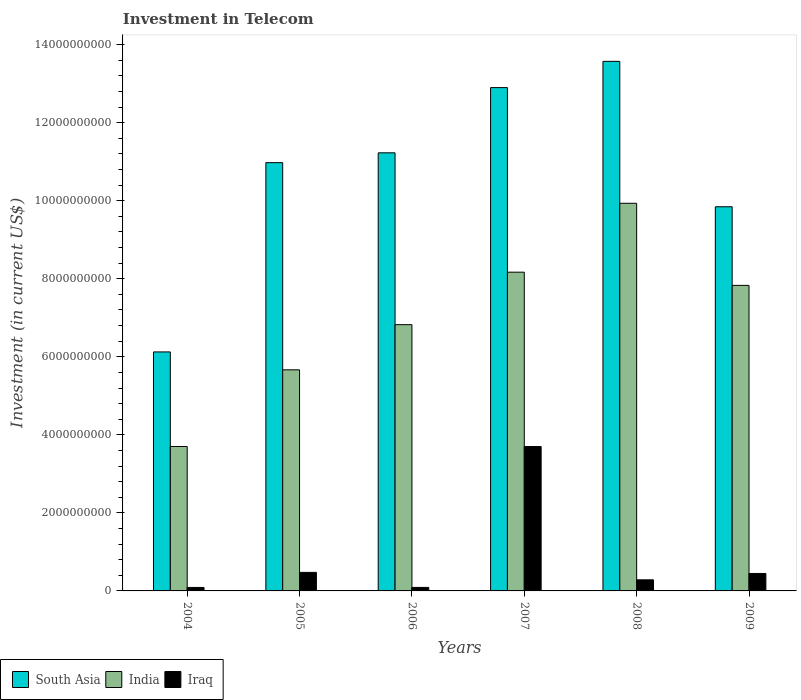Are the number of bars per tick equal to the number of legend labels?
Give a very brief answer. Yes. Are the number of bars on each tick of the X-axis equal?
Provide a short and direct response. Yes. How many bars are there on the 3rd tick from the right?
Keep it short and to the point. 3. In how many cases, is the number of bars for a given year not equal to the number of legend labels?
Ensure brevity in your answer.  0. What is the amount invested in telecom in South Asia in 2006?
Ensure brevity in your answer.  1.12e+1. Across all years, what is the maximum amount invested in telecom in South Asia?
Your response must be concise. 1.36e+1. Across all years, what is the minimum amount invested in telecom in India?
Your answer should be compact. 3.70e+09. In which year was the amount invested in telecom in Iraq maximum?
Offer a very short reply. 2007. What is the total amount invested in telecom in Iraq in the graph?
Ensure brevity in your answer.  5.08e+09. What is the difference between the amount invested in telecom in South Asia in 2004 and that in 2008?
Give a very brief answer. -7.45e+09. What is the difference between the amount invested in telecom in Iraq in 2008 and the amount invested in telecom in South Asia in 2006?
Provide a succinct answer. -1.09e+1. What is the average amount invested in telecom in Iraq per year?
Provide a short and direct response. 8.48e+08. In the year 2009, what is the difference between the amount invested in telecom in Iraq and amount invested in telecom in India?
Offer a very short reply. -7.38e+09. In how many years, is the amount invested in telecom in South Asia greater than 12400000000 US$?
Keep it short and to the point. 2. What is the ratio of the amount invested in telecom in Iraq in 2004 to that in 2009?
Give a very brief answer. 0.2. Is the difference between the amount invested in telecom in Iraq in 2005 and 2006 greater than the difference between the amount invested in telecom in India in 2005 and 2006?
Offer a terse response. Yes. What is the difference between the highest and the second highest amount invested in telecom in India?
Your answer should be compact. 1.77e+09. What is the difference between the highest and the lowest amount invested in telecom in Iraq?
Your response must be concise. 3.61e+09. In how many years, is the amount invested in telecom in Iraq greater than the average amount invested in telecom in Iraq taken over all years?
Provide a succinct answer. 1. Is the sum of the amount invested in telecom in South Asia in 2004 and 2008 greater than the maximum amount invested in telecom in India across all years?
Provide a succinct answer. Yes. What does the 3rd bar from the left in 2006 represents?
Give a very brief answer. Iraq. What does the 2nd bar from the right in 2007 represents?
Your response must be concise. India. Are all the bars in the graph horizontal?
Offer a terse response. No. Does the graph contain any zero values?
Provide a short and direct response. No. Where does the legend appear in the graph?
Give a very brief answer. Bottom left. How are the legend labels stacked?
Offer a terse response. Horizontal. What is the title of the graph?
Give a very brief answer. Investment in Telecom. What is the label or title of the Y-axis?
Keep it short and to the point. Investment (in current US$). What is the Investment (in current US$) of South Asia in 2004?
Keep it short and to the point. 6.12e+09. What is the Investment (in current US$) in India in 2004?
Your response must be concise. 3.70e+09. What is the Investment (in current US$) in Iraq in 2004?
Keep it short and to the point. 8.90e+07. What is the Investment (in current US$) in South Asia in 2005?
Your response must be concise. 1.10e+1. What is the Investment (in current US$) of India in 2005?
Make the answer very short. 5.67e+09. What is the Investment (in current US$) in Iraq in 2005?
Offer a very short reply. 4.75e+08. What is the Investment (in current US$) of South Asia in 2006?
Offer a terse response. 1.12e+1. What is the Investment (in current US$) of India in 2006?
Your answer should be compact. 6.82e+09. What is the Investment (in current US$) in Iraq in 2006?
Give a very brief answer. 9.00e+07. What is the Investment (in current US$) in South Asia in 2007?
Offer a terse response. 1.29e+1. What is the Investment (in current US$) of India in 2007?
Provide a short and direct response. 8.17e+09. What is the Investment (in current US$) in Iraq in 2007?
Give a very brief answer. 3.70e+09. What is the Investment (in current US$) of South Asia in 2008?
Offer a terse response. 1.36e+1. What is the Investment (in current US$) in India in 2008?
Your answer should be compact. 9.93e+09. What is the Investment (in current US$) of Iraq in 2008?
Offer a very short reply. 2.84e+08. What is the Investment (in current US$) in South Asia in 2009?
Provide a short and direct response. 9.84e+09. What is the Investment (in current US$) of India in 2009?
Give a very brief answer. 7.83e+09. What is the Investment (in current US$) of Iraq in 2009?
Offer a very short reply. 4.47e+08. Across all years, what is the maximum Investment (in current US$) of South Asia?
Make the answer very short. 1.36e+1. Across all years, what is the maximum Investment (in current US$) of India?
Offer a terse response. 9.93e+09. Across all years, what is the maximum Investment (in current US$) of Iraq?
Keep it short and to the point. 3.70e+09. Across all years, what is the minimum Investment (in current US$) in South Asia?
Offer a very short reply. 6.12e+09. Across all years, what is the minimum Investment (in current US$) in India?
Your answer should be compact. 3.70e+09. Across all years, what is the minimum Investment (in current US$) of Iraq?
Offer a very short reply. 8.90e+07. What is the total Investment (in current US$) of South Asia in the graph?
Offer a terse response. 6.46e+1. What is the total Investment (in current US$) in India in the graph?
Offer a terse response. 4.21e+1. What is the total Investment (in current US$) in Iraq in the graph?
Provide a short and direct response. 5.08e+09. What is the difference between the Investment (in current US$) of South Asia in 2004 and that in 2005?
Ensure brevity in your answer.  -4.85e+09. What is the difference between the Investment (in current US$) of India in 2004 and that in 2005?
Make the answer very short. -1.96e+09. What is the difference between the Investment (in current US$) of Iraq in 2004 and that in 2005?
Your answer should be very brief. -3.86e+08. What is the difference between the Investment (in current US$) of South Asia in 2004 and that in 2006?
Give a very brief answer. -5.10e+09. What is the difference between the Investment (in current US$) in India in 2004 and that in 2006?
Give a very brief answer. -3.12e+09. What is the difference between the Investment (in current US$) in South Asia in 2004 and that in 2007?
Your answer should be very brief. -6.77e+09. What is the difference between the Investment (in current US$) of India in 2004 and that in 2007?
Your answer should be very brief. -4.47e+09. What is the difference between the Investment (in current US$) of Iraq in 2004 and that in 2007?
Offer a terse response. -3.61e+09. What is the difference between the Investment (in current US$) in South Asia in 2004 and that in 2008?
Provide a succinct answer. -7.45e+09. What is the difference between the Investment (in current US$) in India in 2004 and that in 2008?
Ensure brevity in your answer.  -6.23e+09. What is the difference between the Investment (in current US$) in Iraq in 2004 and that in 2008?
Make the answer very short. -1.95e+08. What is the difference between the Investment (in current US$) in South Asia in 2004 and that in 2009?
Your answer should be very brief. -3.72e+09. What is the difference between the Investment (in current US$) in India in 2004 and that in 2009?
Your answer should be compact. -4.13e+09. What is the difference between the Investment (in current US$) of Iraq in 2004 and that in 2009?
Your answer should be very brief. -3.58e+08. What is the difference between the Investment (in current US$) in South Asia in 2005 and that in 2006?
Offer a terse response. -2.52e+08. What is the difference between the Investment (in current US$) of India in 2005 and that in 2006?
Your answer should be very brief. -1.16e+09. What is the difference between the Investment (in current US$) in Iraq in 2005 and that in 2006?
Your answer should be compact. 3.85e+08. What is the difference between the Investment (in current US$) of South Asia in 2005 and that in 2007?
Offer a terse response. -1.92e+09. What is the difference between the Investment (in current US$) in India in 2005 and that in 2007?
Give a very brief answer. -2.50e+09. What is the difference between the Investment (in current US$) of Iraq in 2005 and that in 2007?
Your response must be concise. -3.22e+09. What is the difference between the Investment (in current US$) of South Asia in 2005 and that in 2008?
Your answer should be very brief. -2.60e+09. What is the difference between the Investment (in current US$) of India in 2005 and that in 2008?
Provide a short and direct response. -4.27e+09. What is the difference between the Investment (in current US$) in Iraq in 2005 and that in 2008?
Offer a terse response. 1.91e+08. What is the difference between the Investment (in current US$) of South Asia in 2005 and that in 2009?
Offer a very short reply. 1.13e+09. What is the difference between the Investment (in current US$) of India in 2005 and that in 2009?
Your answer should be compact. -2.16e+09. What is the difference between the Investment (in current US$) in Iraq in 2005 and that in 2009?
Ensure brevity in your answer.  2.80e+07. What is the difference between the Investment (in current US$) of South Asia in 2006 and that in 2007?
Keep it short and to the point. -1.67e+09. What is the difference between the Investment (in current US$) in India in 2006 and that in 2007?
Offer a terse response. -1.35e+09. What is the difference between the Investment (in current US$) in Iraq in 2006 and that in 2007?
Your answer should be compact. -3.61e+09. What is the difference between the Investment (in current US$) in South Asia in 2006 and that in 2008?
Your response must be concise. -2.34e+09. What is the difference between the Investment (in current US$) in India in 2006 and that in 2008?
Keep it short and to the point. -3.11e+09. What is the difference between the Investment (in current US$) in Iraq in 2006 and that in 2008?
Your answer should be very brief. -1.94e+08. What is the difference between the Investment (in current US$) in South Asia in 2006 and that in 2009?
Keep it short and to the point. 1.38e+09. What is the difference between the Investment (in current US$) in India in 2006 and that in 2009?
Your response must be concise. -1.01e+09. What is the difference between the Investment (in current US$) of Iraq in 2006 and that in 2009?
Ensure brevity in your answer.  -3.57e+08. What is the difference between the Investment (in current US$) in South Asia in 2007 and that in 2008?
Offer a very short reply. -6.73e+08. What is the difference between the Investment (in current US$) in India in 2007 and that in 2008?
Ensure brevity in your answer.  -1.77e+09. What is the difference between the Investment (in current US$) in Iraq in 2007 and that in 2008?
Provide a short and direct response. 3.42e+09. What is the difference between the Investment (in current US$) of South Asia in 2007 and that in 2009?
Your response must be concise. 3.05e+09. What is the difference between the Investment (in current US$) of India in 2007 and that in 2009?
Your answer should be very brief. 3.38e+08. What is the difference between the Investment (in current US$) of Iraq in 2007 and that in 2009?
Ensure brevity in your answer.  3.25e+09. What is the difference between the Investment (in current US$) in South Asia in 2008 and that in 2009?
Provide a succinct answer. 3.73e+09. What is the difference between the Investment (in current US$) in India in 2008 and that in 2009?
Make the answer very short. 2.10e+09. What is the difference between the Investment (in current US$) of Iraq in 2008 and that in 2009?
Provide a succinct answer. -1.63e+08. What is the difference between the Investment (in current US$) of South Asia in 2004 and the Investment (in current US$) of India in 2005?
Give a very brief answer. 4.59e+08. What is the difference between the Investment (in current US$) of South Asia in 2004 and the Investment (in current US$) of Iraq in 2005?
Keep it short and to the point. 5.65e+09. What is the difference between the Investment (in current US$) in India in 2004 and the Investment (in current US$) in Iraq in 2005?
Your response must be concise. 3.23e+09. What is the difference between the Investment (in current US$) in South Asia in 2004 and the Investment (in current US$) in India in 2006?
Keep it short and to the point. -6.99e+08. What is the difference between the Investment (in current US$) of South Asia in 2004 and the Investment (in current US$) of Iraq in 2006?
Give a very brief answer. 6.03e+09. What is the difference between the Investment (in current US$) in India in 2004 and the Investment (in current US$) in Iraq in 2006?
Provide a short and direct response. 3.61e+09. What is the difference between the Investment (in current US$) of South Asia in 2004 and the Investment (in current US$) of India in 2007?
Provide a succinct answer. -2.04e+09. What is the difference between the Investment (in current US$) in South Asia in 2004 and the Investment (in current US$) in Iraq in 2007?
Provide a succinct answer. 2.42e+09. What is the difference between the Investment (in current US$) in India in 2004 and the Investment (in current US$) in Iraq in 2007?
Offer a very short reply. 1.22e+06. What is the difference between the Investment (in current US$) of South Asia in 2004 and the Investment (in current US$) of India in 2008?
Offer a very short reply. -3.81e+09. What is the difference between the Investment (in current US$) in South Asia in 2004 and the Investment (in current US$) in Iraq in 2008?
Your response must be concise. 5.84e+09. What is the difference between the Investment (in current US$) of India in 2004 and the Investment (in current US$) of Iraq in 2008?
Provide a short and direct response. 3.42e+09. What is the difference between the Investment (in current US$) of South Asia in 2004 and the Investment (in current US$) of India in 2009?
Offer a terse response. -1.71e+09. What is the difference between the Investment (in current US$) in South Asia in 2004 and the Investment (in current US$) in Iraq in 2009?
Give a very brief answer. 5.68e+09. What is the difference between the Investment (in current US$) in India in 2004 and the Investment (in current US$) in Iraq in 2009?
Your answer should be very brief. 3.25e+09. What is the difference between the Investment (in current US$) in South Asia in 2005 and the Investment (in current US$) in India in 2006?
Provide a succinct answer. 4.15e+09. What is the difference between the Investment (in current US$) in South Asia in 2005 and the Investment (in current US$) in Iraq in 2006?
Offer a terse response. 1.09e+1. What is the difference between the Investment (in current US$) in India in 2005 and the Investment (in current US$) in Iraq in 2006?
Keep it short and to the point. 5.58e+09. What is the difference between the Investment (in current US$) of South Asia in 2005 and the Investment (in current US$) of India in 2007?
Provide a short and direct response. 2.81e+09. What is the difference between the Investment (in current US$) in South Asia in 2005 and the Investment (in current US$) in Iraq in 2007?
Ensure brevity in your answer.  7.28e+09. What is the difference between the Investment (in current US$) in India in 2005 and the Investment (in current US$) in Iraq in 2007?
Your response must be concise. 1.97e+09. What is the difference between the Investment (in current US$) of South Asia in 2005 and the Investment (in current US$) of India in 2008?
Provide a succinct answer. 1.04e+09. What is the difference between the Investment (in current US$) of South Asia in 2005 and the Investment (in current US$) of Iraq in 2008?
Offer a very short reply. 1.07e+1. What is the difference between the Investment (in current US$) of India in 2005 and the Investment (in current US$) of Iraq in 2008?
Give a very brief answer. 5.38e+09. What is the difference between the Investment (in current US$) of South Asia in 2005 and the Investment (in current US$) of India in 2009?
Ensure brevity in your answer.  3.15e+09. What is the difference between the Investment (in current US$) of South Asia in 2005 and the Investment (in current US$) of Iraq in 2009?
Offer a terse response. 1.05e+1. What is the difference between the Investment (in current US$) of India in 2005 and the Investment (in current US$) of Iraq in 2009?
Keep it short and to the point. 5.22e+09. What is the difference between the Investment (in current US$) in South Asia in 2006 and the Investment (in current US$) in India in 2007?
Ensure brevity in your answer.  3.06e+09. What is the difference between the Investment (in current US$) in South Asia in 2006 and the Investment (in current US$) in Iraq in 2007?
Your answer should be very brief. 7.53e+09. What is the difference between the Investment (in current US$) in India in 2006 and the Investment (in current US$) in Iraq in 2007?
Keep it short and to the point. 3.12e+09. What is the difference between the Investment (in current US$) of South Asia in 2006 and the Investment (in current US$) of India in 2008?
Give a very brief answer. 1.29e+09. What is the difference between the Investment (in current US$) of South Asia in 2006 and the Investment (in current US$) of Iraq in 2008?
Your answer should be compact. 1.09e+1. What is the difference between the Investment (in current US$) in India in 2006 and the Investment (in current US$) in Iraq in 2008?
Keep it short and to the point. 6.54e+09. What is the difference between the Investment (in current US$) in South Asia in 2006 and the Investment (in current US$) in India in 2009?
Provide a short and direct response. 3.40e+09. What is the difference between the Investment (in current US$) in South Asia in 2006 and the Investment (in current US$) in Iraq in 2009?
Give a very brief answer. 1.08e+1. What is the difference between the Investment (in current US$) in India in 2006 and the Investment (in current US$) in Iraq in 2009?
Provide a succinct answer. 6.38e+09. What is the difference between the Investment (in current US$) in South Asia in 2007 and the Investment (in current US$) in India in 2008?
Your answer should be compact. 2.96e+09. What is the difference between the Investment (in current US$) of South Asia in 2007 and the Investment (in current US$) of Iraq in 2008?
Ensure brevity in your answer.  1.26e+1. What is the difference between the Investment (in current US$) of India in 2007 and the Investment (in current US$) of Iraq in 2008?
Keep it short and to the point. 7.88e+09. What is the difference between the Investment (in current US$) in South Asia in 2007 and the Investment (in current US$) in India in 2009?
Your response must be concise. 5.07e+09. What is the difference between the Investment (in current US$) in South Asia in 2007 and the Investment (in current US$) in Iraq in 2009?
Offer a very short reply. 1.25e+1. What is the difference between the Investment (in current US$) of India in 2007 and the Investment (in current US$) of Iraq in 2009?
Your answer should be very brief. 7.72e+09. What is the difference between the Investment (in current US$) in South Asia in 2008 and the Investment (in current US$) in India in 2009?
Offer a very short reply. 5.74e+09. What is the difference between the Investment (in current US$) of South Asia in 2008 and the Investment (in current US$) of Iraq in 2009?
Keep it short and to the point. 1.31e+1. What is the difference between the Investment (in current US$) of India in 2008 and the Investment (in current US$) of Iraq in 2009?
Your response must be concise. 9.49e+09. What is the average Investment (in current US$) of South Asia per year?
Provide a succinct answer. 1.08e+1. What is the average Investment (in current US$) of India per year?
Give a very brief answer. 7.02e+09. What is the average Investment (in current US$) of Iraq per year?
Offer a terse response. 8.48e+08. In the year 2004, what is the difference between the Investment (in current US$) in South Asia and Investment (in current US$) in India?
Give a very brief answer. 2.42e+09. In the year 2004, what is the difference between the Investment (in current US$) in South Asia and Investment (in current US$) in Iraq?
Ensure brevity in your answer.  6.04e+09. In the year 2004, what is the difference between the Investment (in current US$) of India and Investment (in current US$) of Iraq?
Provide a short and direct response. 3.61e+09. In the year 2005, what is the difference between the Investment (in current US$) in South Asia and Investment (in current US$) in India?
Make the answer very short. 5.31e+09. In the year 2005, what is the difference between the Investment (in current US$) in South Asia and Investment (in current US$) in Iraq?
Keep it short and to the point. 1.05e+1. In the year 2005, what is the difference between the Investment (in current US$) of India and Investment (in current US$) of Iraq?
Your answer should be compact. 5.19e+09. In the year 2006, what is the difference between the Investment (in current US$) in South Asia and Investment (in current US$) in India?
Your answer should be compact. 4.40e+09. In the year 2006, what is the difference between the Investment (in current US$) of South Asia and Investment (in current US$) of Iraq?
Your answer should be compact. 1.11e+1. In the year 2006, what is the difference between the Investment (in current US$) in India and Investment (in current US$) in Iraq?
Keep it short and to the point. 6.73e+09. In the year 2007, what is the difference between the Investment (in current US$) in South Asia and Investment (in current US$) in India?
Ensure brevity in your answer.  4.73e+09. In the year 2007, what is the difference between the Investment (in current US$) of South Asia and Investment (in current US$) of Iraq?
Your answer should be compact. 9.20e+09. In the year 2007, what is the difference between the Investment (in current US$) in India and Investment (in current US$) in Iraq?
Provide a short and direct response. 4.47e+09. In the year 2008, what is the difference between the Investment (in current US$) of South Asia and Investment (in current US$) of India?
Ensure brevity in your answer.  3.64e+09. In the year 2008, what is the difference between the Investment (in current US$) of South Asia and Investment (in current US$) of Iraq?
Keep it short and to the point. 1.33e+1. In the year 2008, what is the difference between the Investment (in current US$) of India and Investment (in current US$) of Iraq?
Your answer should be very brief. 9.65e+09. In the year 2009, what is the difference between the Investment (in current US$) in South Asia and Investment (in current US$) in India?
Provide a short and direct response. 2.01e+09. In the year 2009, what is the difference between the Investment (in current US$) in South Asia and Investment (in current US$) in Iraq?
Ensure brevity in your answer.  9.40e+09. In the year 2009, what is the difference between the Investment (in current US$) of India and Investment (in current US$) of Iraq?
Offer a terse response. 7.38e+09. What is the ratio of the Investment (in current US$) in South Asia in 2004 to that in 2005?
Your answer should be compact. 0.56. What is the ratio of the Investment (in current US$) of India in 2004 to that in 2005?
Your answer should be compact. 0.65. What is the ratio of the Investment (in current US$) in Iraq in 2004 to that in 2005?
Offer a very short reply. 0.19. What is the ratio of the Investment (in current US$) of South Asia in 2004 to that in 2006?
Offer a very short reply. 0.55. What is the ratio of the Investment (in current US$) in India in 2004 to that in 2006?
Offer a very short reply. 0.54. What is the ratio of the Investment (in current US$) in Iraq in 2004 to that in 2006?
Provide a succinct answer. 0.99. What is the ratio of the Investment (in current US$) of South Asia in 2004 to that in 2007?
Give a very brief answer. 0.47. What is the ratio of the Investment (in current US$) in India in 2004 to that in 2007?
Your answer should be compact. 0.45. What is the ratio of the Investment (in current US$) in Iraq in 2004 to that in 2007?
Keep it short and to the point. 0.02. What is the ratio of the Investment (in current US$) in South Asia in 2004 to that in 2008?
Give a very brief answer. 0.45. What is the ratio of the Investment (in current US$) of India in 2004 to that in 2008?
Ensure brevity in your answer.  0.37. What is the ratio of the Investment (in current US$) of Iraq in 2004 to that in 2008?
Offer a terse response. 0.31. What is the ratio of the Investment (in current US$) in South Asia in 2004 to that in 2009?
Provide a short and direct response. 0.62. What is the ratio of the Investment (in current US$) in India in 2004 to that in 2009?
Your answer should be very brief. 0.47. What is the ratio of the Investment (in current US$) in Iraq in 2004 to that in 2009?
Your response must be concise. 0.2. What is the ratio of the Investment (in current US$) in South Asia in 2005 to that in 2006?
Offer a terse response. 0.98. What is the ratio of the Investment (in current US$) in India in 2005 to that in 2006?
Ensure brevity in your answer.  0.83. What is the ratio of the Investment (in current US$) of Iraq in 2005 to that in 2006?
Your answer should be very brief. 5.28. What is the ratio of the Investment (in current US$) of South Asia in 2005 to that in 2007?
Your response must be concise. 0.85. What is the ratio of the Investment (in current US$) of India in 2005 to that in 2007?
Make the answer very short. 0.69. What is the ratio of the Investment (in current US$) in Iraq in 2005 to that in 2007?
Give a very brief answer. 0.13. What is the ratio of the Investment (in current US$) of South Asia in 2005 to that in 2008?
Ensure brevity in your answer.  0.81. What is the ratio of the Investment (in current US$) of India in 2005 to that in 2008?
Keep it short and to the point. 0.57. What is the ratio of the Investment (in current US$) in Iraq in 2005 to that in 2008?
Provide a short and direct response. 1.67. What is the ratio of the Investment (in current US$) of South Asia in 2005 to that in 2009?
Keep it short and to the point. 1.11. What is the ratio of the Investment (in current US$) in India in 2005 to that in 2009?
Ensure brevity in your answer.  0.72. What is the ratio of the Investment (in current US$) of Iraq in 2005 to that in 2009?
Your response must be concise. 1.06. What is the ratio of the Investment (in current US$) in South Asia in 2006 to that in 2007?
Offer a very short reply. 0.87. What is the ratio of the Investment (in current US$) of India in 2006 to that in 2007?
Offer a very short reply. 0.84. What is the ratio of the Investment (in current US$) of Iraq in 2006 to that in 2007?
Your answer should be very brief. 0.02. What is the ratio of the Investment (in current US$) of South Asia in 2006 to that in 2008?
Your answer should be very brief. 0.83. What is the ratio of the Investment (in current US$) of India in 2006 to that in 2008?
Provide a succinct answer. 0.69. What is the ratio of the Investment (in current US$) in Iraq in 2006 to that in 2008?
Make the answer very short. 0.32. What is the ratio of the Investment (in current US$) of South Asia in 2006 to that in 2009?
Provide a succinct answer. 1.14. What is the ratio of the Investment (in current US$) in India in 2006 to that in 2009?
Your answer should be compact. 0.87. What is the ratio of the Investment (in current US$) of Iraq in 2006 to that in 2009?
Keep it short and to the point. 0.2. What is the ratio of the Investment (in current US$) of South Asia in 2007 to that in 2008?
Keep it short and to the point. 0.95. What is the ratio of the Investment (in current US$) in India in 2007 to that in 2008?
Make the answer very short. 0.82. What is the ratio of the Investment (in current US$) in Iraq in 2007 to that in 2008?
Offer a very short reply. 13.03. What is the ratio of the Investment (in current US$) of South Asia in 2007 to that in 2009?
Ensure brevity in your answer.  1.31. What is the ratio of the Investment (in current US$) in India in 2007 to that in 2009?
Offer a terse response. 1.04. What is the ratio of the Investment (in current US$) in Iraq in 2007 to that in 2009?
Ensure brevity in your answer.  8.28. What is the ratio of the Investment (in current US$) in South Asia in 2008 to that in 2009?
Offer a very short reply. 1.38. What is the ratio of the Investment (in current US$) of India in 2008 to that in 2009?
Make the answer very short. 1.27. What is the ratio of the Investment (in current US$) of Iraq in 2008 to that in 2009?
Ensure brevity in your answer.  0.64. What is the difference between the highest and the second highest Investment (in current US$) of South Asia?
Your answer should be compact. 6.73e+08. What is the difference between the highest and the second highest Investment (in current US$) in India?
Provide a succinct answer. 1.77e+09. What is the difference between the highest and the second highest Investment (in current US$) of Iraq?
Your answer should be compact. 3.22e+09. What is the difference between the highest and the lowest Investment (in current US$) in South Asia?
Provide a succinct answer. 7.45e+09. What is the difference between the highest and the lowest Investment (in current US$) of India?
Ensure brevity in your answer.  6.23e+09. What is the difference between the highest and the lowest Investment (in current US$) of Iraq?
Your response must be concise. 3.61e+09. 